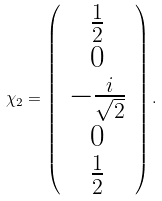<formula> <loc_0><loc_0><loc_500><loc_500>\chi _ { 2 } = \left ( \begin{array} { c } \frac { 1 } { 2 } \\ 0 \\ - \frac { i } { \sqrt { 2 } } \\ 0 \\ \frac { 1 } { 2 } \end{array} \right ) .</formula> 